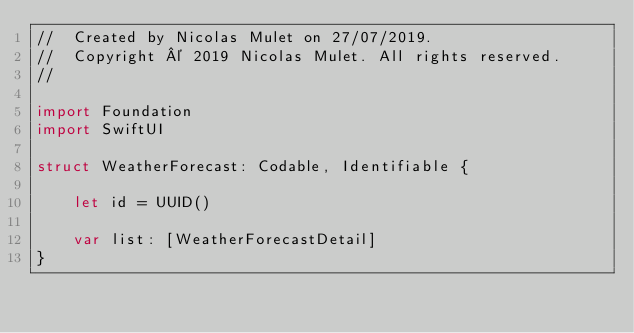<code> <loc_0><loc_0><loc_500><loc_500><_Swift_>//  Created by Nicolas Mulet on 27/07/2019.
//  Copyright © 2019 Nicolas Mulet. All rights reserved.
//

import Foundation
import SwiftUI

struct WeatherForecast: Codable, Identifiable {
    
    let id = UUID()
    
    var list: [WeatherForecastDetail]
}
</code> 